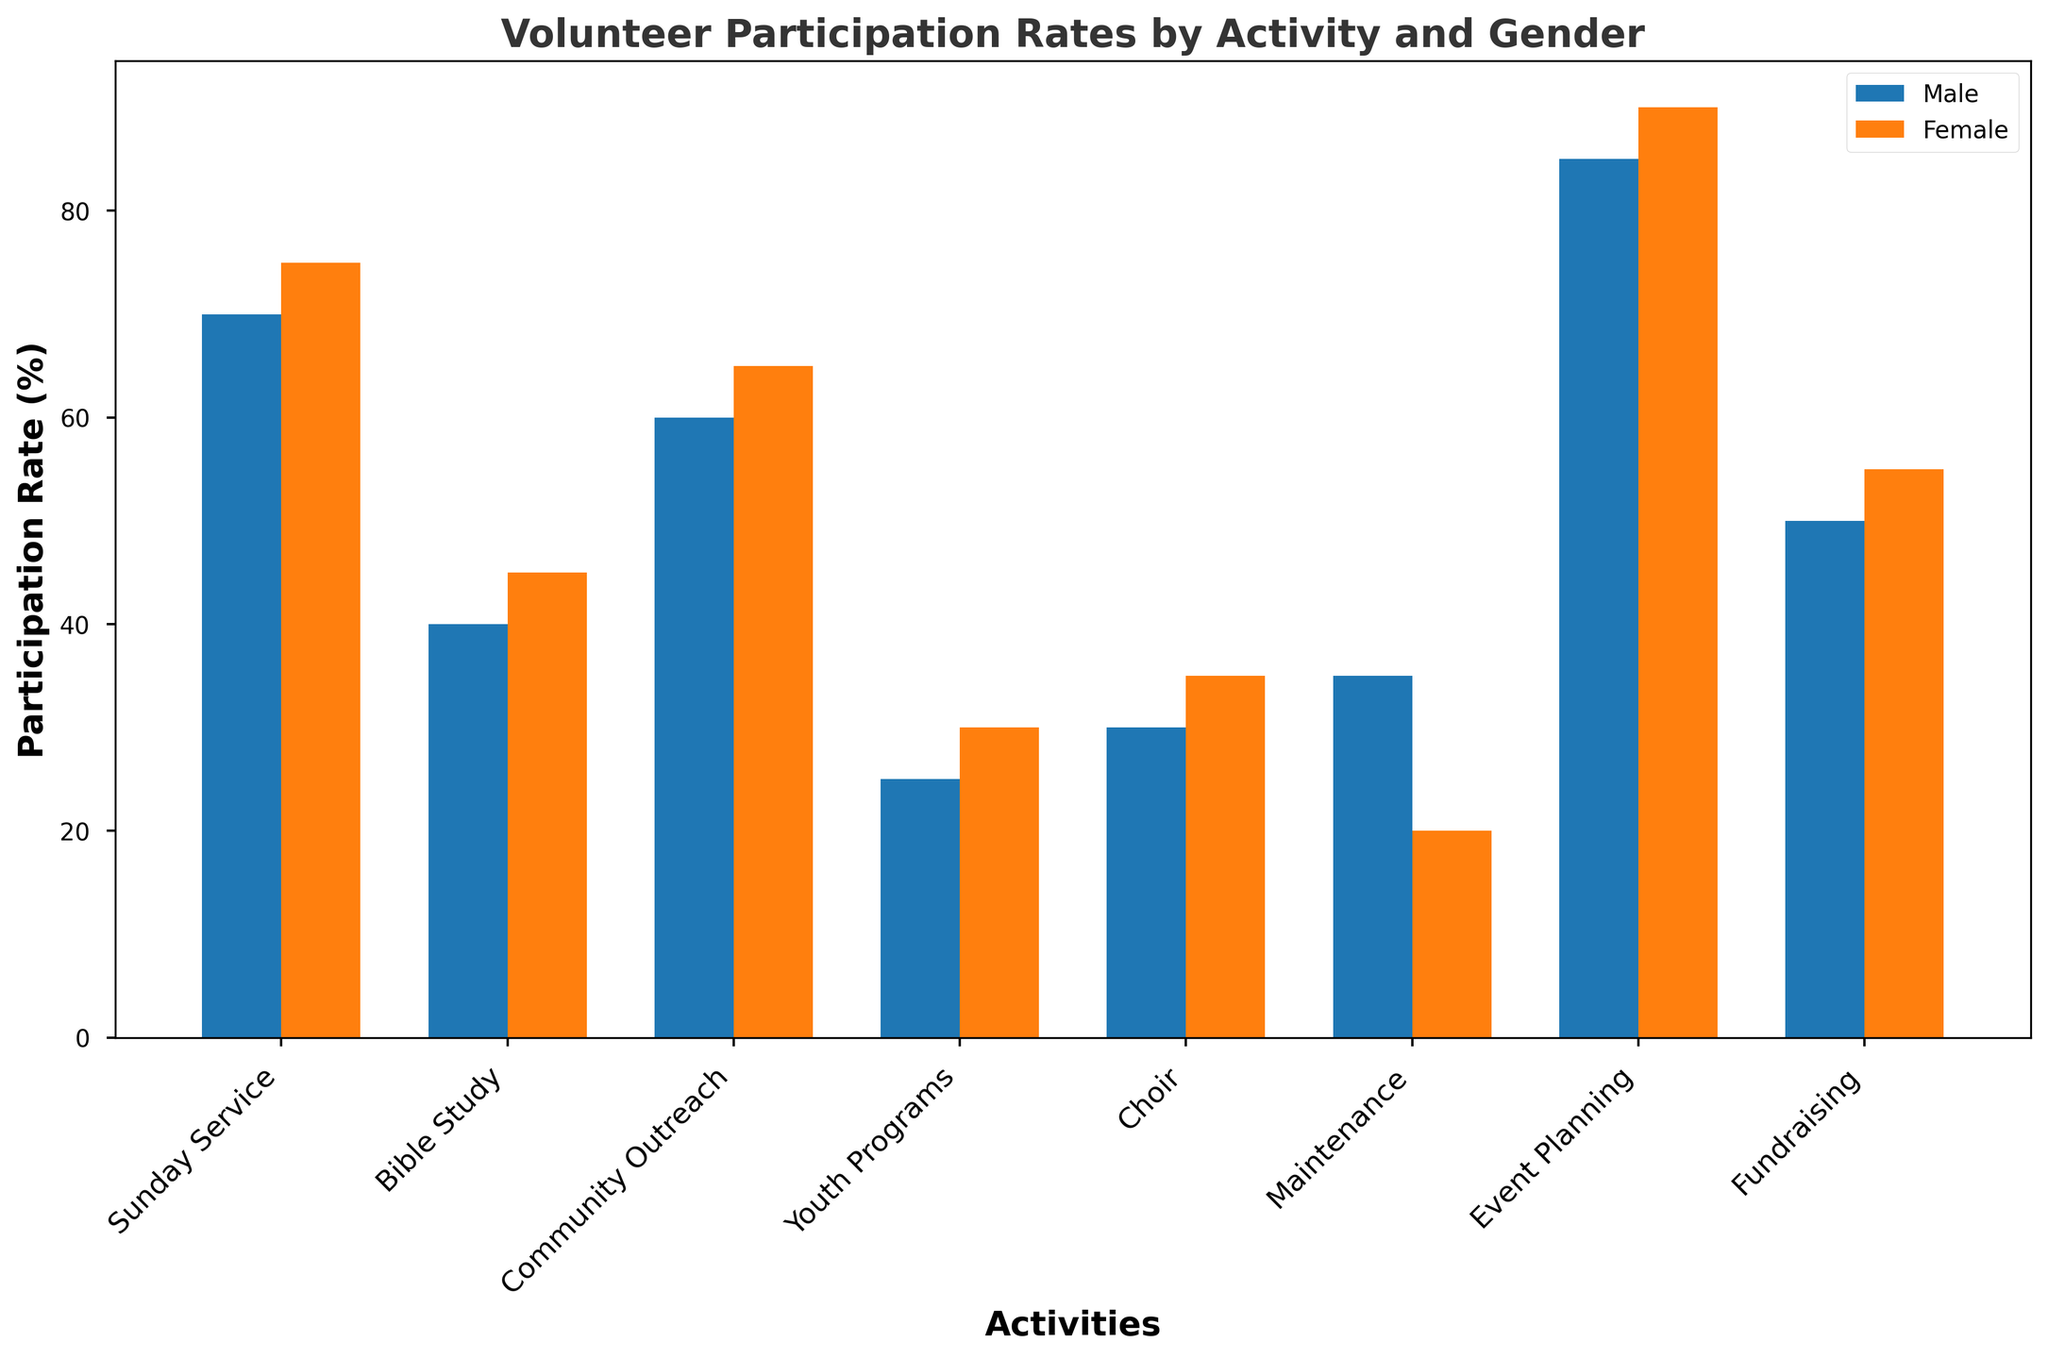Which gender has a higher participation rate in Community Outreach? To determine which gender has a higher participation rate in Community Outreach, look at the bars for Community Outreach and compare their heights. The bar for females is higher than the bar for males.
Answer: Female What activity has the largest gender gap in volunteer participation rates? To find the activity with the largest gender gap, calculate the absolute difference between male and female participation rates for each activity. Maintenance has a gap of 15% (35% for males and 20% for females), which is the largest.
Answer: Maintenance Which activity has the lowest participation rate among males? To identify the activity with the lowest male participation rate, look for the shortest bar among the male participation bars. Event Planning has the lowest male participation rate at 25%.
Answer: Event Planning Which activity has the smallest difference in participation rates between genders? To determine the smallest difference, calculate the absolute difference between male and female participation rates for each activity. Choir has a difference of 5% (40% for males and 45% for females), which is the smallest.
Answer: Choir What is the average female participation rate across all activities? Sum the female participation rates and divide by the number of activities: (90+75+65+55+45+20+30+35)/8 = 51.25%.
Answer: 51.25% Is the male participation rate in Bible Study higher or lower than in Youth Programs? Compare the heights of the bars representing male participation in Bible Study and Youth Programs. The Bible Study participation rate (70%) is higher than Youth Programs (50%).
Answer: Higher By how many percentage points is the Female participation rate in Sunday Service higher than the Male participation rate in Sunday Service? Subtract the male participation rate for Sunday Service from the female participation rate: 90% - 85% = 5%.
Answer: 5% Which activity has the smallest total participation rate (combining both genders)? Add male and female participation rates for each activity and identify the activity with the smallest sum. Event Planning has the smallest total participation rate: 25% + 30% = 55%.
Answer: Event Planning What is the total participation rate of males in all activities? Sum the male participation rates across all activities: 85 + 70 + 60 + 50 + 40 + 35 + 25 + 30 = 395%.
Answer: 395% Which activity sees an equal number of male and female participants? Look for activities where the heights of the male and female bars are equal. There are no activities with equal male and female participation rates in the data provided.
Answer: None 